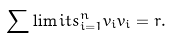<formula> <loc_0><loc_0><loc_500><loc_500>\sum \lim i t s _ { i = 1 } ^ { n } { v _ { i } v _ { i } } = r .</formula> 